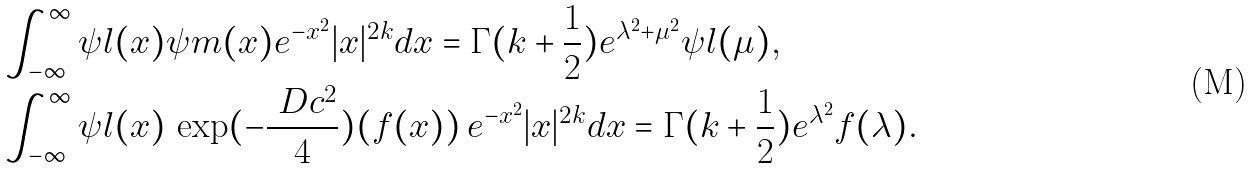<formula> <loc_0><loc_0><loc_500><loc_500>& \int _ { - \infty } ^ { \infty } \psi l ( x ) \psi m ( x ) e ^ { - x ^ { 2 } } | x | ^ { 2 k } d x = \Gamma ( k + \frac { 1 } { 2 } ) e ^ { \lambda ^ { 2 } + \mu ^ { 2 } } \psi l ( \mu ) , \\ & \int _ { - \infty } ^ { \infty } \psi l ( x ) \, \exp ( - \frac { \ D c ^ { 2 } } { 4 } ) ( f ( x ) ) \, e ^ { - x ^ { 2 } } | x | ^ { 2 k } d x = \Gamma ( k + \frac { 1 } { 2 } ) e ^ { \lambda ^ { 2 } } f ( \lambda ) .</formula> 